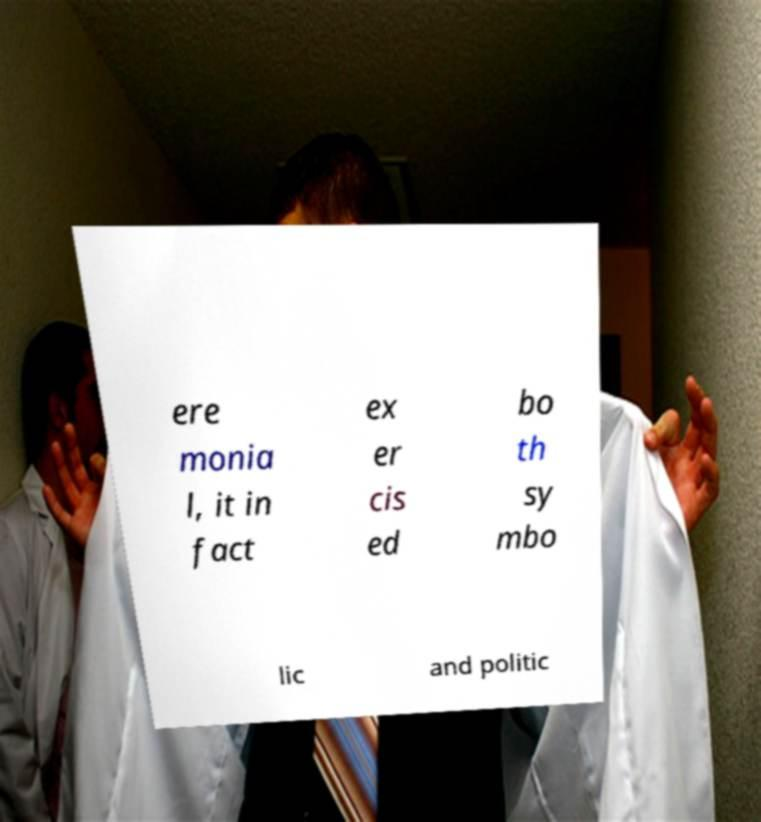There's text embedded in this image that I need extracted. Can you transcribe it verbatim? ere monia l, it in fact ex er cis ed bo th sy mbo lic and politic 